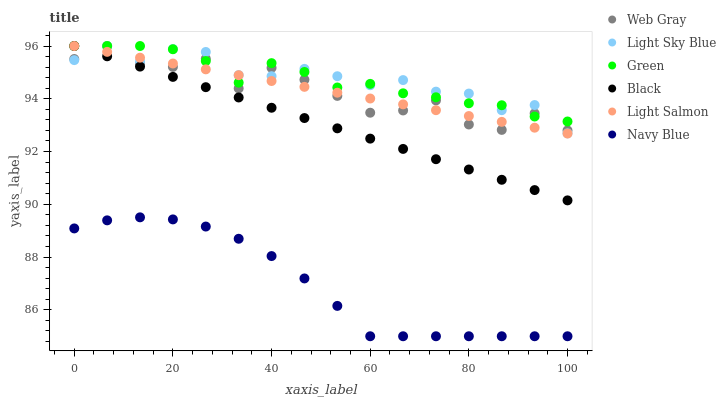Does Navy Blue have the minimum area under the curve?
Answer yes or no. Yes. Does Light Sky Blue have the maximum area under the curve?
Answer yes or no. Yes. Does Web Gray have the minimum area under the curve?
Answer yes or no. No. Does Web Gray have the maximum area under the curve?
Answer yes or no. No. Is Light Salmon the smoothest?
Answer yes or no. Yes. Is Web Gray the roughest?
Answer yes or no. Yes. Is Navy Blue the smoothest?
Answer yes or no. No. Is Navy Blue the roughest?
Answer yes or no. No. Does Navy Blue have the lowest value?
Answer yes or no. Yes. Does Web Gray have the lowest value?
Answer yes or no. No. Does Green have the highest value?
Answer yes or no. Yes. Does Navy Blue have the highest value?
Answer yes or no. No. Is Navy Blue less than Web Gray?
Answer yes or no. Yes. Is Web Gray greater than Navy Blue?
Answer yes or no. Yes. Does Light Sky Blue intersect Black?
Answer yes or no. Yes. Is Light Sky Blue less than Black?
Answer yes or no. No. Is Light Sky Blue greater than Black?
Answer yes or no. No. Does Navy Blue intersect Web Gray?
Answer yes or no. No. 